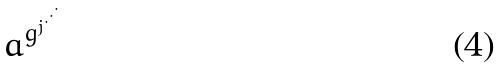<formula> <loc_0><loc_0><loc_500><loc_500>a ^ { g ^ { j ^ { \cdot ^ { \cdot ^ { \cdot } } } } }</formula> 